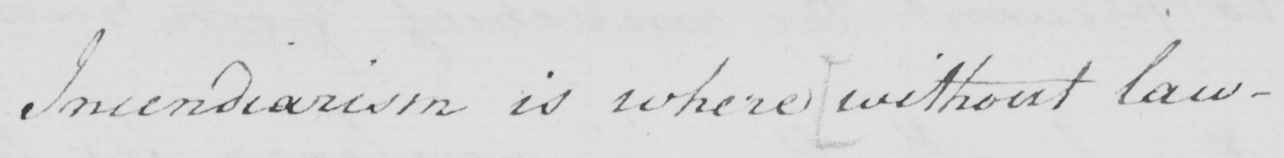Can you read and transcribe this handwriting? Incendiarism is where  [ without law- 